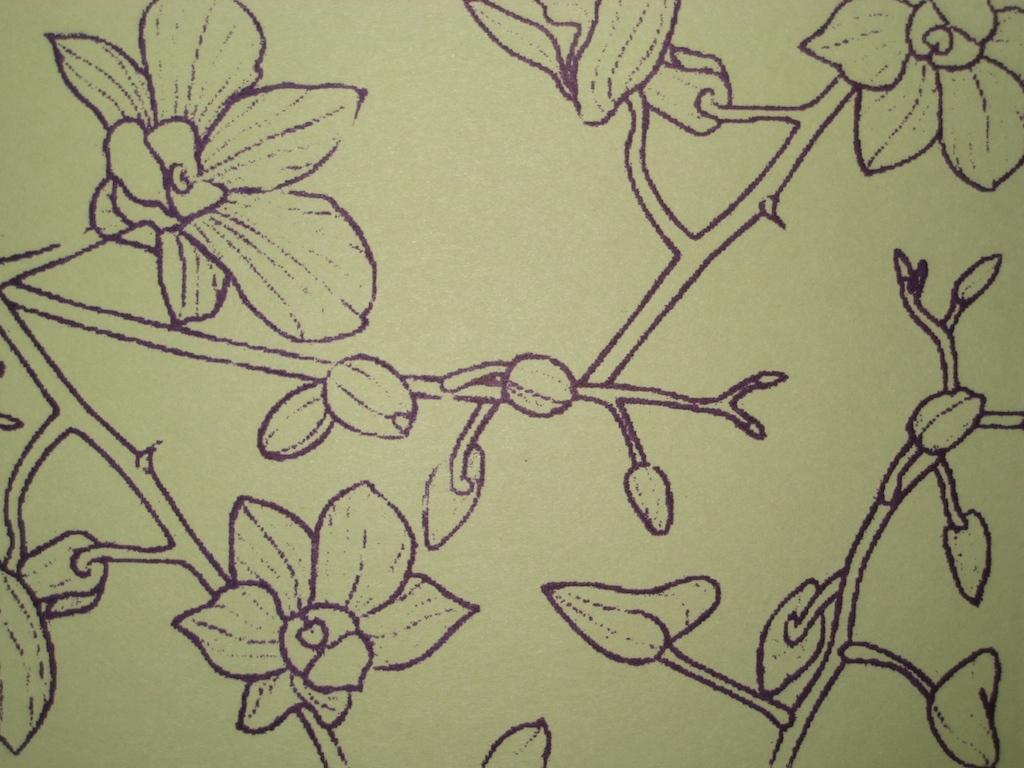What type of drawing can be seen on the wall in the image? There is a drawing of a flower on the wall. Are there any other drawings of plants on the wall? Yes, there is a drawing of plants on the wall. How do the boys in the image contribute to the growth of the plants? There are no boys present in the image, so their behavior and contribution to the growth of the plants cannot be determined. 